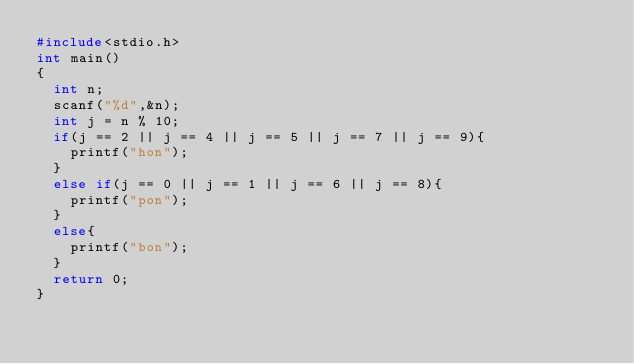Convert code to text. <code><loc_0><loc_0><loc_500><loc_500><_C_>#include<stdio.h>
int main()
{
  int n;
  scanf("%d",&n);
  int j = n % 10;
  if(j == 2 || j == 4 || j == 5 || j == 7 || j == 9){
   	printf("hon");
  }
  else if(j == 0 || j == 1 || j == 6 || j == 8){
  	printf("pon");
  }
  else{
  	printf("bon");
  }
  return 0;
}
    </code> 